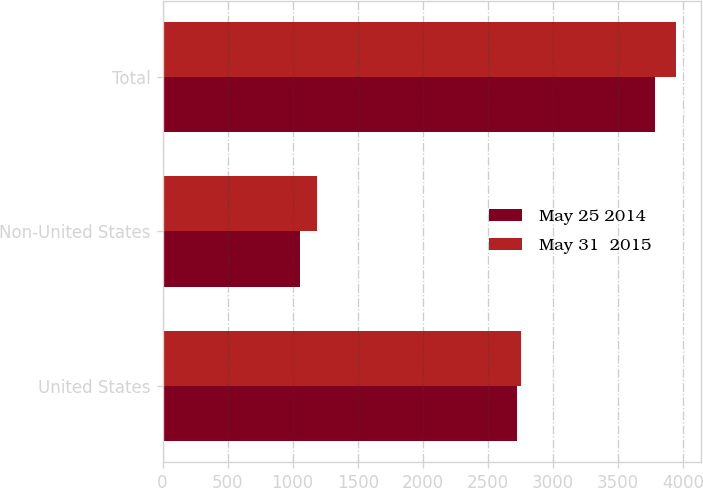Convert chart to OTSL. <chart><loc_0><loc_0><loc_500><loc_500><stacked_bar_chart><ecel><fcel>United States<fcel>Non-United States<fcel>Total<nl><fcel>May 25 2014<fcel>2727.5<fcel>1055.8<fcel>3783.3<nl><fcel>May 31  2015<fcel>2756.6<fcel>1185.3<fcel>3941.9<nl></chart> 